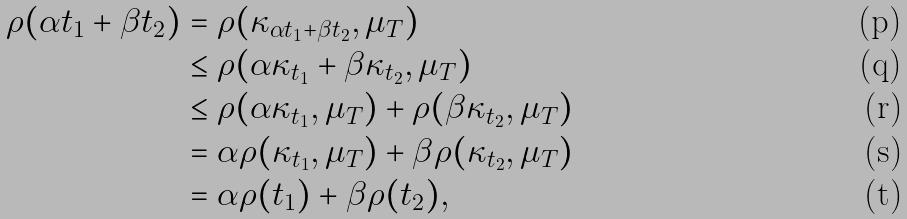Convert formula to latex. <formula><loc_0><loc_0><loc_500><loc_500>\rho ( \alpha t _ { 1 } + \beta t _ { 2 } ) & = \rho ( \kappa _ { \alpha t _ { 1 } + \beta t _ { 2 } } , \mu _ { T } ) \\ & \leq \rho ( \alpha \kappa _ { t _ { 1 } } + \beta \kappa _ { t _ { 2 } } , \mu _ { T } ) \\ & \leq \rho ( \alpha \kappa _ { t _ { 1 } } , \mu _ { T } ) + \rho ( \beta \kappa _ { t _ { 2 } } , \mu _ { T } ) \\ & = \alpha \rho ( \kappa _ { t _ { 1 } } , \mu _ { T } ) + \beta \rho ( \kappa _ { t _ { 2 } } , \mu _ { T } ) \\ & = \alpha \rho ( t _ { 1 } ) + \beta \rho ( t _ { 2 } ) ,</formula> 